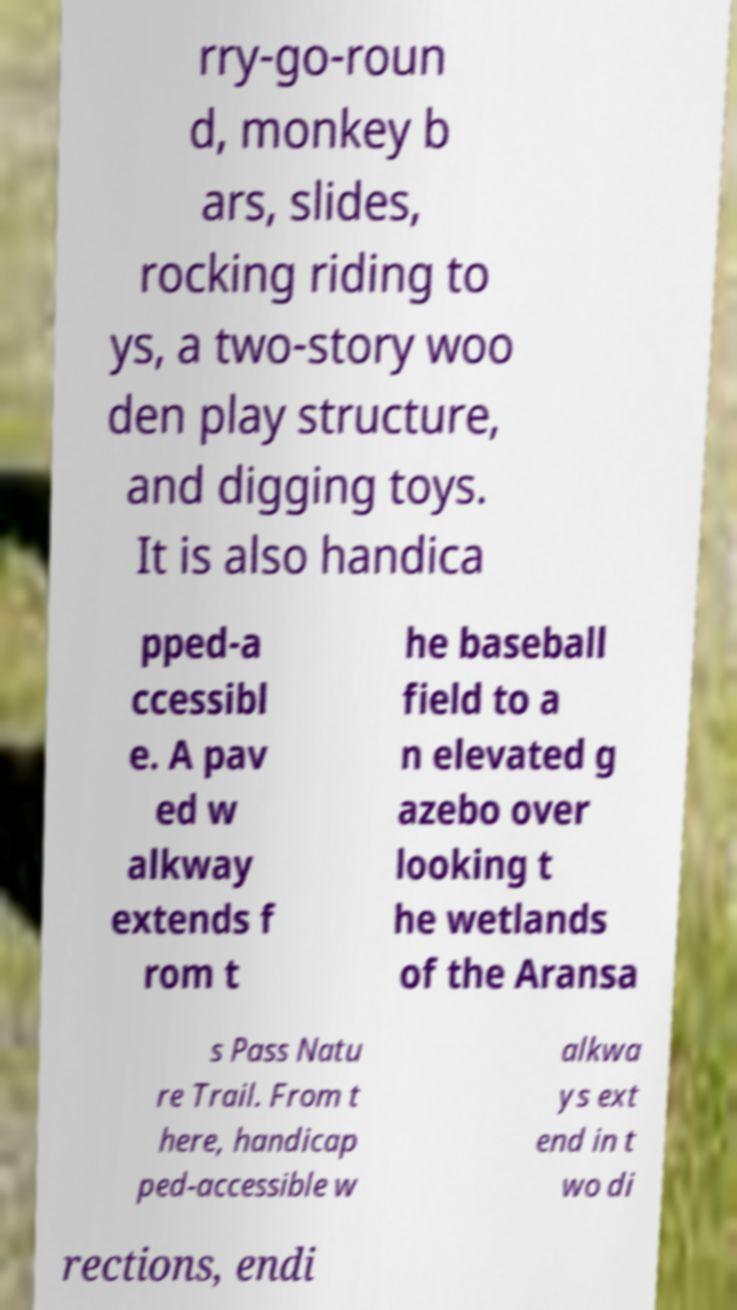I need the written content from this picture converted into text. Can you do that? rry-go-roun d, monkey b ars, slides, rocking riding to ys, a two-story woo den play structure, and digging toys. It is also handica pped-a ccessibl e. A pav ed w alkway extends f rom t he baseball field to a n elevated g azebo over looking t he wetlands of the Aransa s Pass Natu re Trail. From t here, handicap ped-accessible w alkwa ys ext end in t wo di rections, endi 